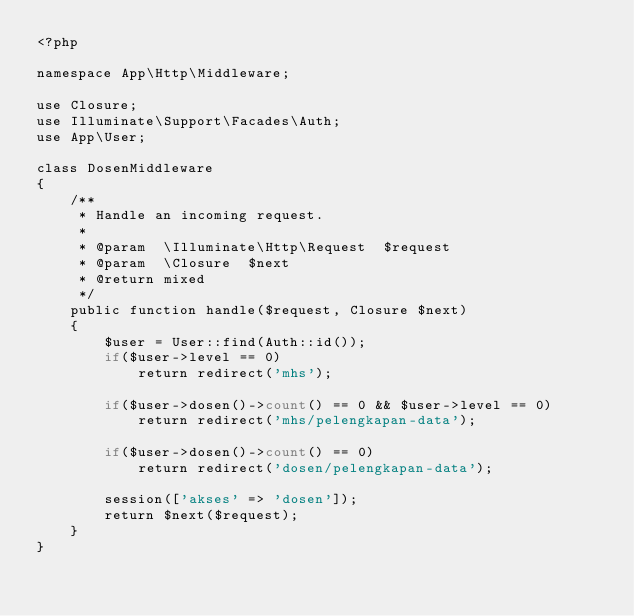Convert code to text. <code><loc_0><loc_0><loc_500><loc_500><_PHP_><?php

namespace App\Http\Middleware;

use Closure;
use Illuminate\Support\Facades\Auth;
use App\User;

class DosenMiddleware
{
    /**
     * Handle an incoming request.
     *
     * @param  \Illuminate\Http\Request  $request
     * @param  \Closure  $next
     * @return mixed
     */
    public function handle($request, Closure $next)
    {
        $user = User::find(Auth::id());
        if($user->level == 0)
            return redirect('mhs');

        if($user->dosen()->count() == 0 && $user->level == 0)
            return redirect('mhs/pelengkapan-data');

        if($user->dosen()->count() == 0)
            return redirect('dosen/pelengkapan-data');

        session(['akses' => 'dosen']);
        return $next($request);
    }
}
</code> 